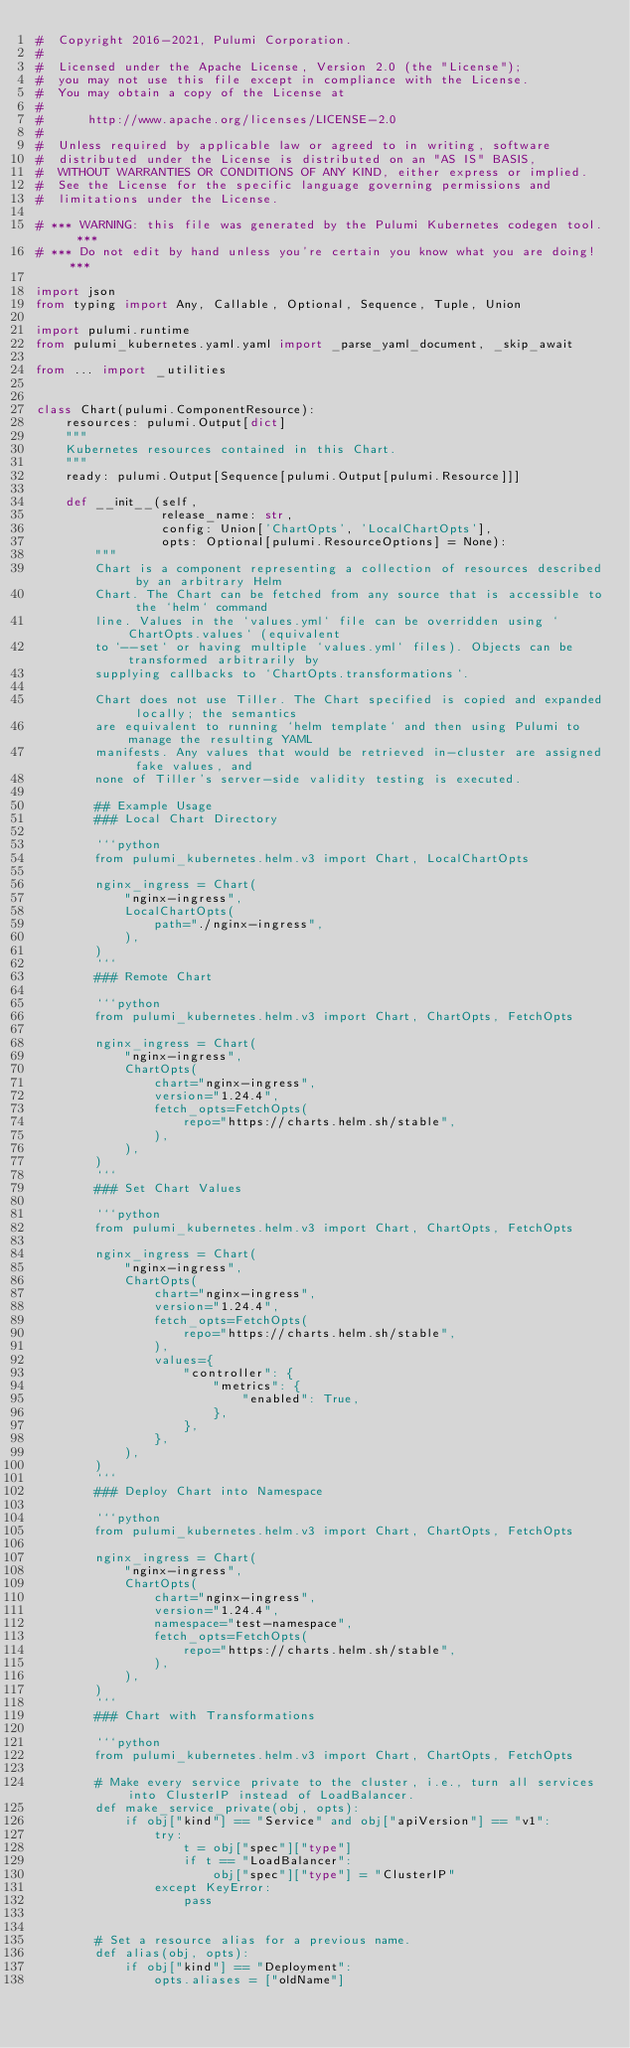<code> <loc_0><loc_0><loc_500><loc_500><_Python_>#  Copyright 2016-2021, Pulumi Corporation.
#
#  Licensed under the Apache License, Version 2.0 (the "License");
#  you may not use this file except in compliance with the License.
#  You may obtain a copy of the License at
#
#      http://www.apache.org/licenses/LICENSE-2.0
#
#  Unless required by applicable law or agreed to in writing, software
#  distributed under the License is distributed on an "AS IS" BASIS,
#  WITHOUT WARRANTIES OR CONDITIONS OF ANY KIND, either express or implied.
#  See the License for the specific language governing permissions and
#  limitations under the License.

# *** WARNING: this file was generated by the Pulumi Kubernetes codegen tool. ***
# *** Do not edit by hand unless you're certain you know what you are doing! ***

import json
from typing import Any, Callable, Optional, Sequence, Tuple, Union

import pulumi.runtime
from pulumi_kubernetes.yaml.yaml import _parse_yaml_document, _skip_await

from ... import _utilities


class Chart(pulumi.ComponentResource):
    resources: pulumi.Output[dict]
    """
    Kubernetes resources contained in this Chart.
    """
    ready: pulumi.Output[Sequence[pulumi.Output[pulumi.Resource]]]

    def __init__(self,
                 release_name: str,
                 config: Union['ChartOpts', 'LocalChartOpts'],
                 opts: Optional[pulumi.ResourceOptions] = None):
        """
        Chart is a component representing a collection of resources described by an arbitrary Helm
        Chart. The Chart can be fetched from any source that is accessible to the `helm` command
        line. Values in the `values.yml` file can be overridden using `ChartOpts.values` (equivalent
        to `--set` or having multiple `values.yml` files). Objects can be transformed arbitrarily by
        supplying callbacks to `ChartOpts.transformations`.

        Chart does not use Tiller. The Chart specified is copied and expanded locally; the semantics
        are equivalent to running `helm template` and then using Pulumi to manage the resulting YAML
        manifests. Any values that would be retrieved in-cluster are assigned fake values, and
        none of Tiller's server-side validity testing is executed.

        ## Example Usage
        ### Local Chart Directory

        ```python
        from pulumi_kubernetes.helm.v3 import Chart, LocalChartOpts

        nginx_ingress = Chart(
            "nginx-ingress",
            LocalChartOpts(
                path="./nginx-ingress",
            ),
        )
        ```
        ### Remote Chart

        ```python
        from pulumi_kubernetes.helm.v3 import Chart, ChartOpts, FetchOpts

        nginx_ingress = Chart(
            "nginx-ingress",
            ChartOpts(
                chart="nginx-ingress",
                version="1.24.4",
                fetch_opts=FetchOpts(
                    repo="https://charts.helm.sh/stable",
                ),
            ),
        )
        ```
        ### Set Chart Values

        ```python
        from pulumi_kubernetes.helm.v3 import Chart, ChartOpts, FetchOpts

        nginx_ingress = Chart(
            "nginx-ingress",
            ChartOpts(
                chart="nginx-ingress",
                version="1.24.4",
                fetch_opts=FetchOpts(
                    repo="https://charts.helm.sh/stable",
                ),
                values={
                    "controller": {
                        "metrics": {
                            "enabled": True,
                        },
                    },
                },
            ),
        )
        ```
        ### Deploy Chart into Namespace

        ```python
        from pulumi_kubernetes.helm.v3 import Chart, ChartOpts, FetchOpts

        nginx_ingress = Chart(
            "nginx-ingress",
            ChartOpts(
                chart="nginx-ingress",
                version="1.24.4",
                namespace="test-namespace",
                fetch_opts=FetchOpts(
                    repo="https://charts.helm.sh/stable",
                ),
            ),
        )
        ```
        ### Chart with Transformations

        ```python
        from pulumi_kubernetes.helm.v3 import Chart, ChartOpts, FetchOpts

        # Make every service private to the cluster, i.e., turn all services into ClusterIP instead of LoadBalancer.
        def make_service_private(obj, opts):
            if obj["kind"] == "Service" and obj["apiVersion"] == "v1":
                try:
                    t = obj["spec"]["type"]
                    if t == "LoadBalancer":
                        obj["spec"]["type"] = "ClusterIP"
                except KeyError:
                    pass


        # Set a resource alias for a previous name.
        def alias(obj, opts):
            if obj["kind"] == "Deployment":
                opts.aliases = ["oldName"]

</code> 